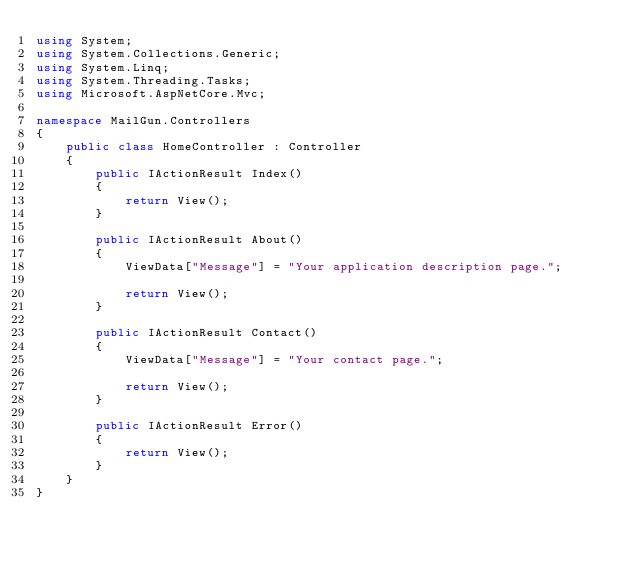Convert code to text. <code><loc_0><loc_0><loc_500><loc_500><_C#_>using System;
using System.Collections.Generic;
using System.Linq;
using System.Threading.Tasks;
using Microsoft.AspNetCore.Mvc;

namespace MailGun.Controllers
{
    public class HomeController : Controller
    {
        public IActionResult Index()
        {
            return View();
        }

        public IActionResult About()
        {
            ViewData["Message"] = "Your application description page.";

            return View();
        }

        public IActionResult Contact()
        {
            ViewData["Message"] = "Your contact page.";

            return View();
        }

        public IActionResult Error()
        {
            return View();
        }
    }
}
</code> 